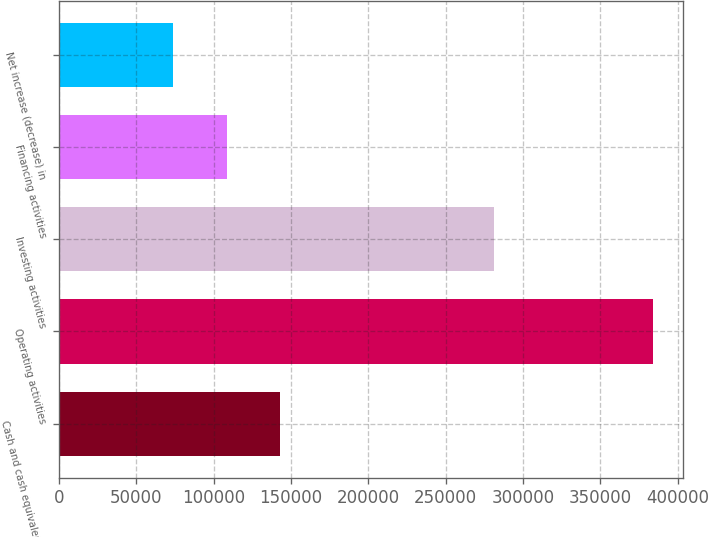<chart> <loc_0><loc_0><loc_500><loc_500><bar_chart><fcel>Cash and cash equivalents at<fcel>Operating activities<fcel>Investing activities<fcel>Financing activities<fcel>Net increase (decrease) in<nl><fcel>142955<fcel>384192<fcel>281512<fcel>108493<fcel>74030.4<nl></chart> 